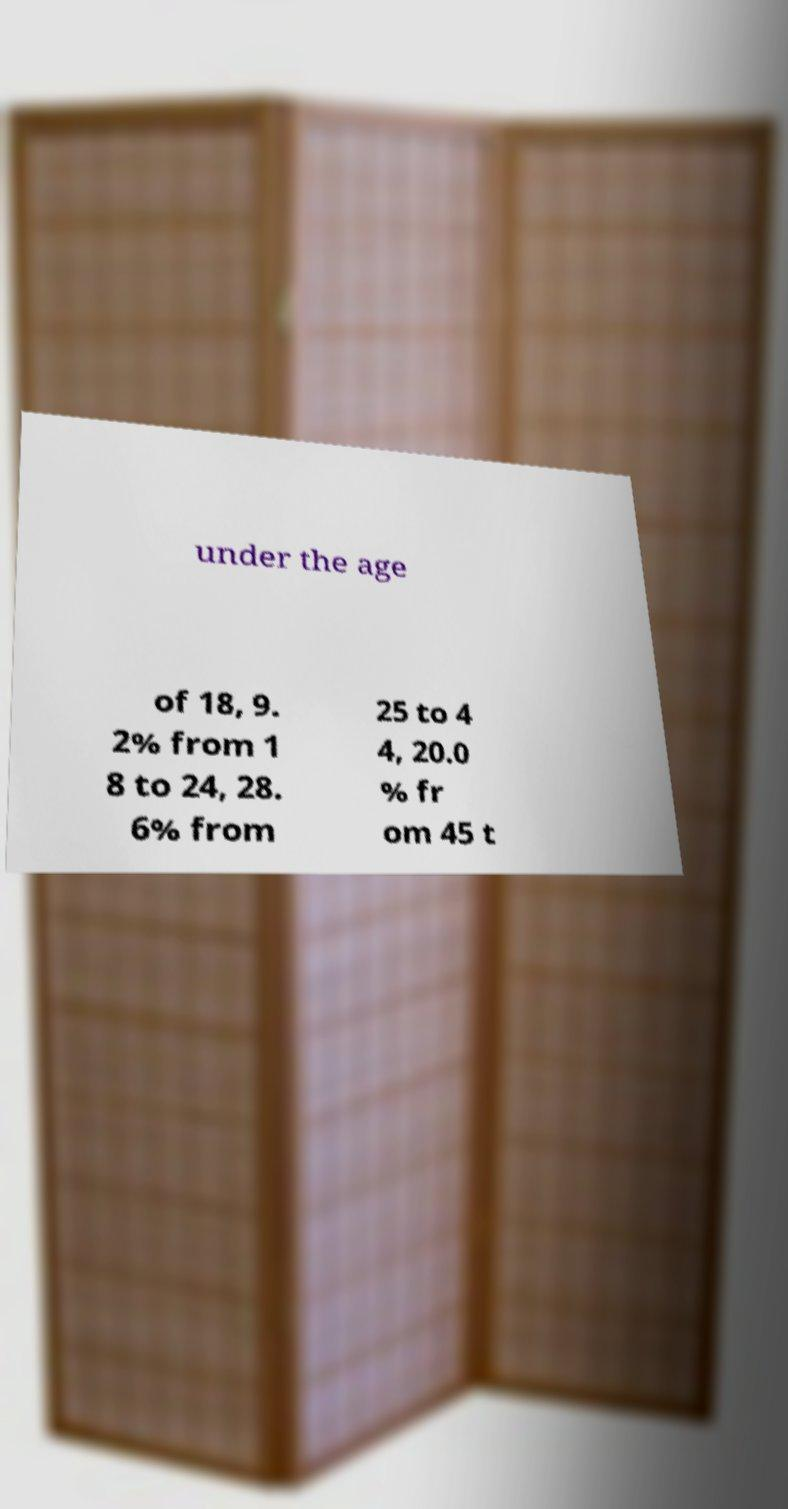There's text embedded in this image that I need extracted. Can you transcribe it verbatim? under the age of 18, 9. 2% from 1 8 to 24, 28. 6% from 25 to 4 4, 20.0 % fr om 45 t 